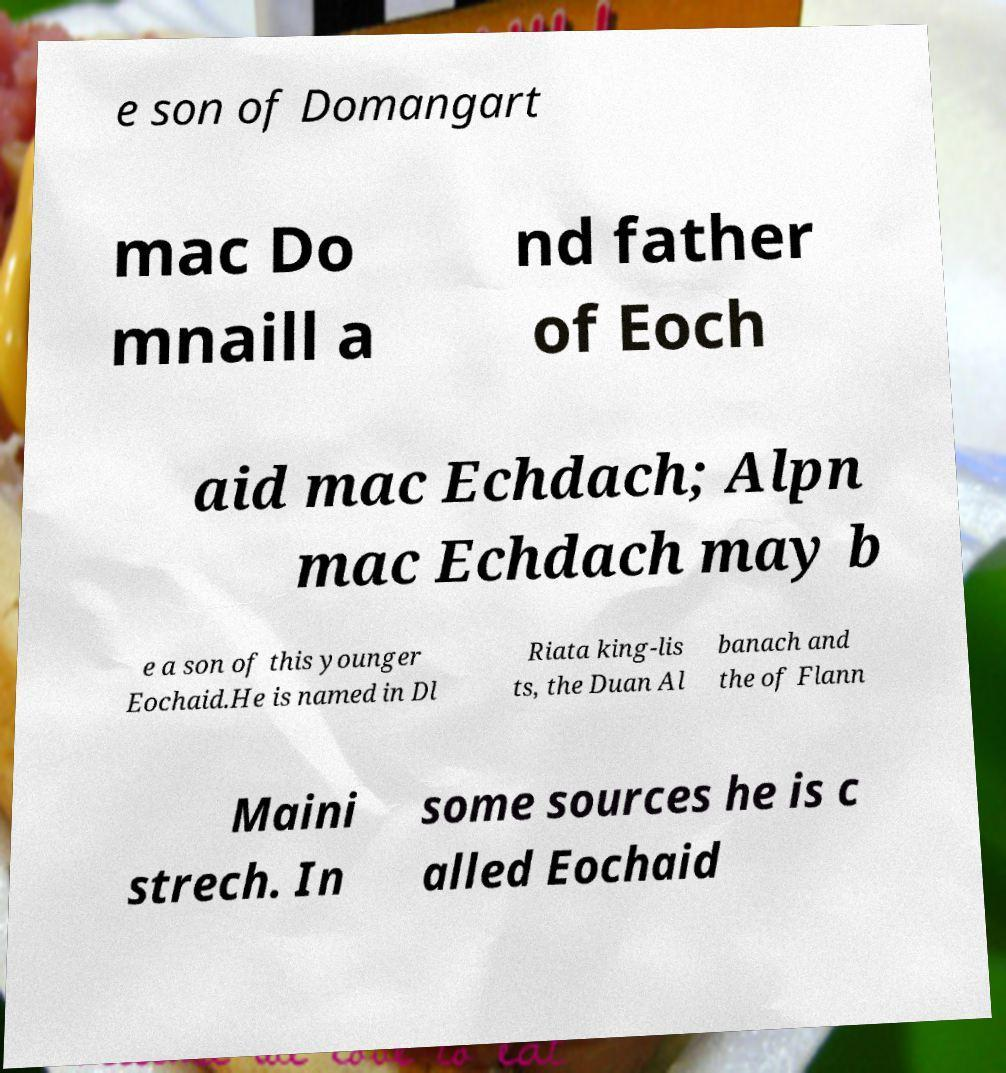Please read and relay the text visible in this image. What does it say? e son of Domangart mac Do mnaill a nd father of Eoch aid mac Echdach; Alpn mac Echdach may b e a son of this younger Eochaid.He is named in Dl Riata king-lis ts, the Duan Al banach and the of Flann Maini strech. In some sources he is c alled Eochaid 